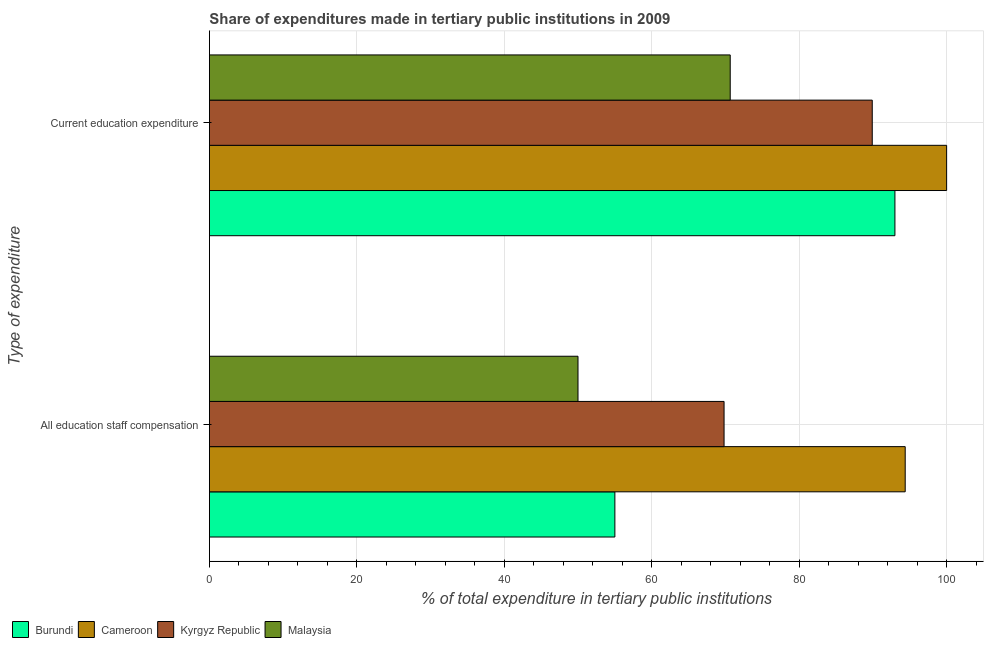How many groups of bars are there?
Provide a succinct answer. 2. Are the number of bars per tick equal to the number of legend labels?
Your answer should be compact. Yes. How many bars are there on the 2nd tick from the top?
Keep it short and to the point. 4. How many bars are there on the 2nd tick from the bottom?
Ensure brevity in your answer.  4. What is the label of the 1st group of bars from the top?
Your answer should be very brief. Current education expenditure. What is the expenditure in staff compensation in Burundi?
Offer a terse response. 55. Across all countries, what is the maximum expenditure in staff compensation?
Give a very brief answer. 94.38. Across all countries, what is the minimum expenditure in staff compensation?
Give a very brief answer. 50. In which country was the expenditure in education maximum?
Keep it short and to the point. Cameroon. In which country was the expenditure in education minimum?
Ensure brevity in your answer.  Malaysia. What is the total expenditure in education in the graph?
Keep it short and to the point. 353.54. What is the difference between the expenditure in staff compensation in Cameroon and that in Burundi?
Ensure brevity in your answer.  39.38. What is the difference between the expenditure in education in Burundi and the expenditure in staff compensation in Kyrgyz Republic?
Keep it short and to the point. 23.17. What is the average expenditure in education per country?
Keep it short and to the point. 88.39. What is the difference between the expenditure in education and expenditure in staff compensation in Cameroon?
Your response must be concise. 5.62. What is the ratio of the expenditure in education in Kyrgyz Republic to that in Cameroon?
Keep it short and to the point. 0.9. Is the expenditure in staff compensation in Malaysia less than that in Cameroon?
Keep it short and to the point. Yes. What does the 4th bar from the top in Current education expenditure represents?
Your answer should be compact. Burundi. What does the 4th bar from the bottom in Current education expenditure represents?
Provide a short and direct response. Malaysia. What is the difference between two consecutive major ticks on the X-axis?
Offer a very short reply. 20. Does the graph contain grids?
Give a very brief answer. Yes. How many legend labels are there?
Your answer should be compact. 4. How are the legend labels stacked?
Give a very brief answer. Horizontal. What is the title of the graph?
Keep it short and to the point. Share of expenditures made in tertiary public institutions in 2009. What is the label or title of the X-axis?
Give a very brief answer. % of total expenditure in tertiary public institutions. What is the label or title of the Y-axis?
Give a very brief answer. Type of expenditure. What is the % of total expenditure in tertiary public institutions of Burundi in All education staff compensation?
Offer a terse response. 55. What is the % of total expenditure in tertiary public institutions in Cameroon in All education staff compensation?
Make the answer very short. 94.38. What is the % of total expenditure in tertiary public institutions of Kyrgyz Republic in All education staff compensation?
Provide a short and direct response. 69.81. What is the % of total expenditure in tertiary public institutions of Malaysia in All education staff compensation?
Give a very brief answer. 50. What is the % of total expenditure in tertiary public institutions of Burundi in Current education expenditure?
Offer a very short reply. 92.99. What is the % of total expenditure in tertiary public institutions in Kyrgyz Republic in Current education expenditure?
Offer a terse response. 89.91. What is the % of total expenditure in tertiary public institutions of Malaysia in Current education expenditure?
Your response must be concise. 70.64. Across all Type of expenditure, what is the maximum % of total expenditure in tertiary public institutions in Burundi?
Provide a succinct answer. 92.99. Across all Type of expenditure, what is the maximum % of total expenditure in tertiary public institutions in Cameroon?
Provide a short and direct response. 100. Across all Type of expenditure, what is the maximum % of total expenditure in tertiary public institutions in Kyrgyz Republic?
Your answer should be compact. 89.91. Across all Type of expenditure, what is the maximum % of total expenditure in tertiary public institutions in Malaysia?
Your response must be concise. 70.64. Across all Type of expenditure, what is the minimum % of total expenditure in tertiary public institutions of Burundi?
Ensure brevity in your answer.  55. Across all Type of expenditure, what is the minimum % of total expenditure in tertiary public institutions of Cameroon?
Ensure brevity in your answer.  94.38. Across all Type of expenditure, what is the minimum % of total expenditure in tertiary public institutions in Kyrgyz Republic?
Keep it short and to the point. 69.81. Across all Type of expenditure, what is the minimum % of total expenditure in tertiary public institutions of Malaysia?
Give a very brief answer. 50. What is the total % of total expenditure in tertiary public institutions of Burundi in the graph?
Make the answer very short. 147.98. What is the total % of total expenditure in tertiary public institutions of Cameroon in the graph?
Give a very brief answer. 194.38. What is the total % of total expenditure in tertiary public institutions in Kyrgyz Republic in the graph?
Your answer should be compact. 159.72. What is the total % of total expenditure in tertiary public institutions of Malaysia in the graph?
Make the answer very short. 120.64. What is the difference between the % of total expenditure in tertiary public institutions in Burundi in All education staff compensation and that in Current education expenditure?
Your answer should be compact. -37.99. What is the difference between the % of total expenditure in tertiary public institutions of Cameroon in All education staff compensation and that in Current education expenditure?
Offer a very short reply. -5.62. What is the difference between the % of total expenditure in tertiary public institutions in Kyrgyz Republic in All education staff compensation and that in Current education expenditure?
Ensure brevity in your answer.  -20.1. What is the difference between the % of total expenditure in tertiary public institutions of Malaysia in All education staff compensation and that in Current education expenditure?
Offer a terse response. -20.65. What is the difference between the % of total expenditure in tertiary public institutions in Burundi in All education staff compensation and the % of total expenditure in tertiary public institutions in Cameroon in Current education expenditure?
Provide a short and direct response. -45. What is the difference between the % of total expenditure in tertiary public institutions of Burundi in All education staff compensation and the % of total expenditure in tertiary public institutions of Kyrgyz Republic in Current education expenditure?
Give a very brief answer. -34.91. What is the difference between the % of total expenditure in tertiary public institutions in Burundi in All education staff compensation and the % of total expenditure in tertiary public institutions in Malaysia in Current education expenditure?
Provide a short and direct response. -15.65. What is the difference between the % of total expenditure in tertiary public institutions in Cameroon in All education staff compensation and the % of total expenditure in tertiary public institutions in Kyrgyz Republic in Current education expenditure?
Your answer should be compact. 4.47. What is the difference between the % of total expenditure in tertiary public institutions in Cameroon in All education staff compensation and the % of total expenditure in tertiary public institutions in Malaysia in Current education expenditure?
Provide a short and direct response. 23.74. What is the difference between the % of total expenditure in tertiary public institutions of Kyrgyz Republic in All education staff compensation and the % of total expenditure in tertiary public institutions of Malaysia in Current education expenditure?
Provide a succinct answer. -0.83. What is the average % of total expenditure in tertiary public institutions of Burundi per Type of expenditure?
Keep it short and to the point. 73.99. What is the average % of total expenditure in tertiary public institutions of Cameroon per Type of expenditure?
Offer a terse response. 97.19. What is the average % of total expenditure in tertiary public institutions of Kyrgyz Republic per Type of expenditure?
Offer a terse response. 79.86. What is the average % of total expenditure in tertiary public institutions of Malaysia per Type of expenditure?
Offer a very short reply. 60.32. What is the difference between the % of total expenditure in tertiary public institutions of Burundi and % of total expenditure in tertiary public institutions of Cameroon in All education staff compensation?
Keep it short and to the point. -39.38. What is the difference between the % of total expenditure in tertiary public institutions of Burundi and % of total expenditure in tertiary public institutions of Kyrgyz Republic in All education staff compensation?
Give a very brief answer. -14.81. What is the difference between the % of total expenditure in tertiary public institutions of Burundi and % of total expenditure in tertiary public institutions of Malaysia in All education staff compensation?
Keep it short and to the point. 5. What is the difference between the % of total expenditure in tertiary public institutions in Cameroon and % of total expenditure in tertiary public institutions in Kyrgyz Republic in All education staff compensation?
Provide a succinct answer. 24.57. What is the difference between the % of total expenditure in tertiary public institutions of Cameroon and % of total expenditure in tertiary public institutions of Malaysia in All education staff compensation?
Offer a very short reply. 44.38. What is the difference between the % of total expenditure in tertiary public institutions of Kyrgyz Republic and % of total expenditure in tertiary public institutions of Malaysia in All education staff compensation?
Provide a succinct answer. 19.81. What is the difference between the % of total expenditure in tertiary public institutions of Burundi and % of total expenditure in tertiary public institutions of Cameroon in Current education expenditure?
Ensure brevity in your answer.  -7.01. What is the difference between the % of total expenditure in tertiary public institutions in Burundi and % of total expenditure in tertiary public institutions in Kyrgyz Republic in Current education expenditure?
Keep it short and to the point. 3.07. What is the difference between the % of total expenditure in tertiary public institutions of Burundi and % of total expenditure in tertiary public institutions of Malaysia in Current education expenditure?
Your response must be concise. 22.34. What is the difference between the % of total expenditure in tertiary public institutions of Cameroon and % of total expenditure in tertiary public institutions of Kyrgyz Republic in Current education expenditure?
Offer a terse response. 10.09. What is the difference between the % of total expenditure in tertiary public institutions of Cameroon and % of total expenditure in tertiary public institutions of Malaysia in Current education expenditure?
Offer a very short reply. 29.36. What is the difference between the % of total expenditure in tertiary public institutions of Kyrgyz Republic and % of total expenditure in tertiary public institutions of Malaysia in Current education expenditure?
Provide a short and direct response. 19.27. What is the ratio of the % of total expenditure in tertiary public institutions of Burundi in All education staff compensation to that in Current education expenditure?
Offer a terse response. 0.59. What is the ratio of the % of total expenditure in tertiary public institutions in Cameroon in All education staff compensation to that in Current education expenditure?
Your answer should be compact. 0.94. What is the ratio of the % of total expenditure in tertiary public institutions of Kyrgyz Republic in All education staff compensation to that in Current education expenditure?
Offer a terse response. 0.78. What is the ratio of the % of total expenditure in tertiary public institutions of Malaysia in All education staff compensation to that in Current education expenditure?
Ensure brevity in your answer.  0.71. What is the difference between the highest and the second highest % of total expenditure in tertiary public institutions of Burundi?
Give a very brief answer. 37.99. What is the difference between the highest and the second highest % of total expenditure in tertiary public institutions in Cameroon?
Provide a short and direct response. 5.62. What is the difference between the highest and the second highest % of total expenditure in tertiary public institutions of Kyrgyz Republic?
Offer a very short reply. 20.1. What is the difference between the highest and the second highest % of total expenditure in tertiary public institutions of Malaysia?
Your response must be concise. 20.65. What is the difference between the highest and the lowest % of total expenditure in tertiary public institutions of Burundi?
Your answer should be compact. 37.99. What is the difference between the highest and the lowest % of total expenditure in tertiary public institutions of Cameroon?
Your answer should be compact. 5.62. What is the difference between the highest and the lowest % of total expenditure in tertiary public institutions in Kyrgyz Republic?
Make the answer very short. 20.1. What is the difference between the highest and the lowest % of total expenditure in tertiary public institutions of Malaysia?
Your response must be concise. 20.65. 